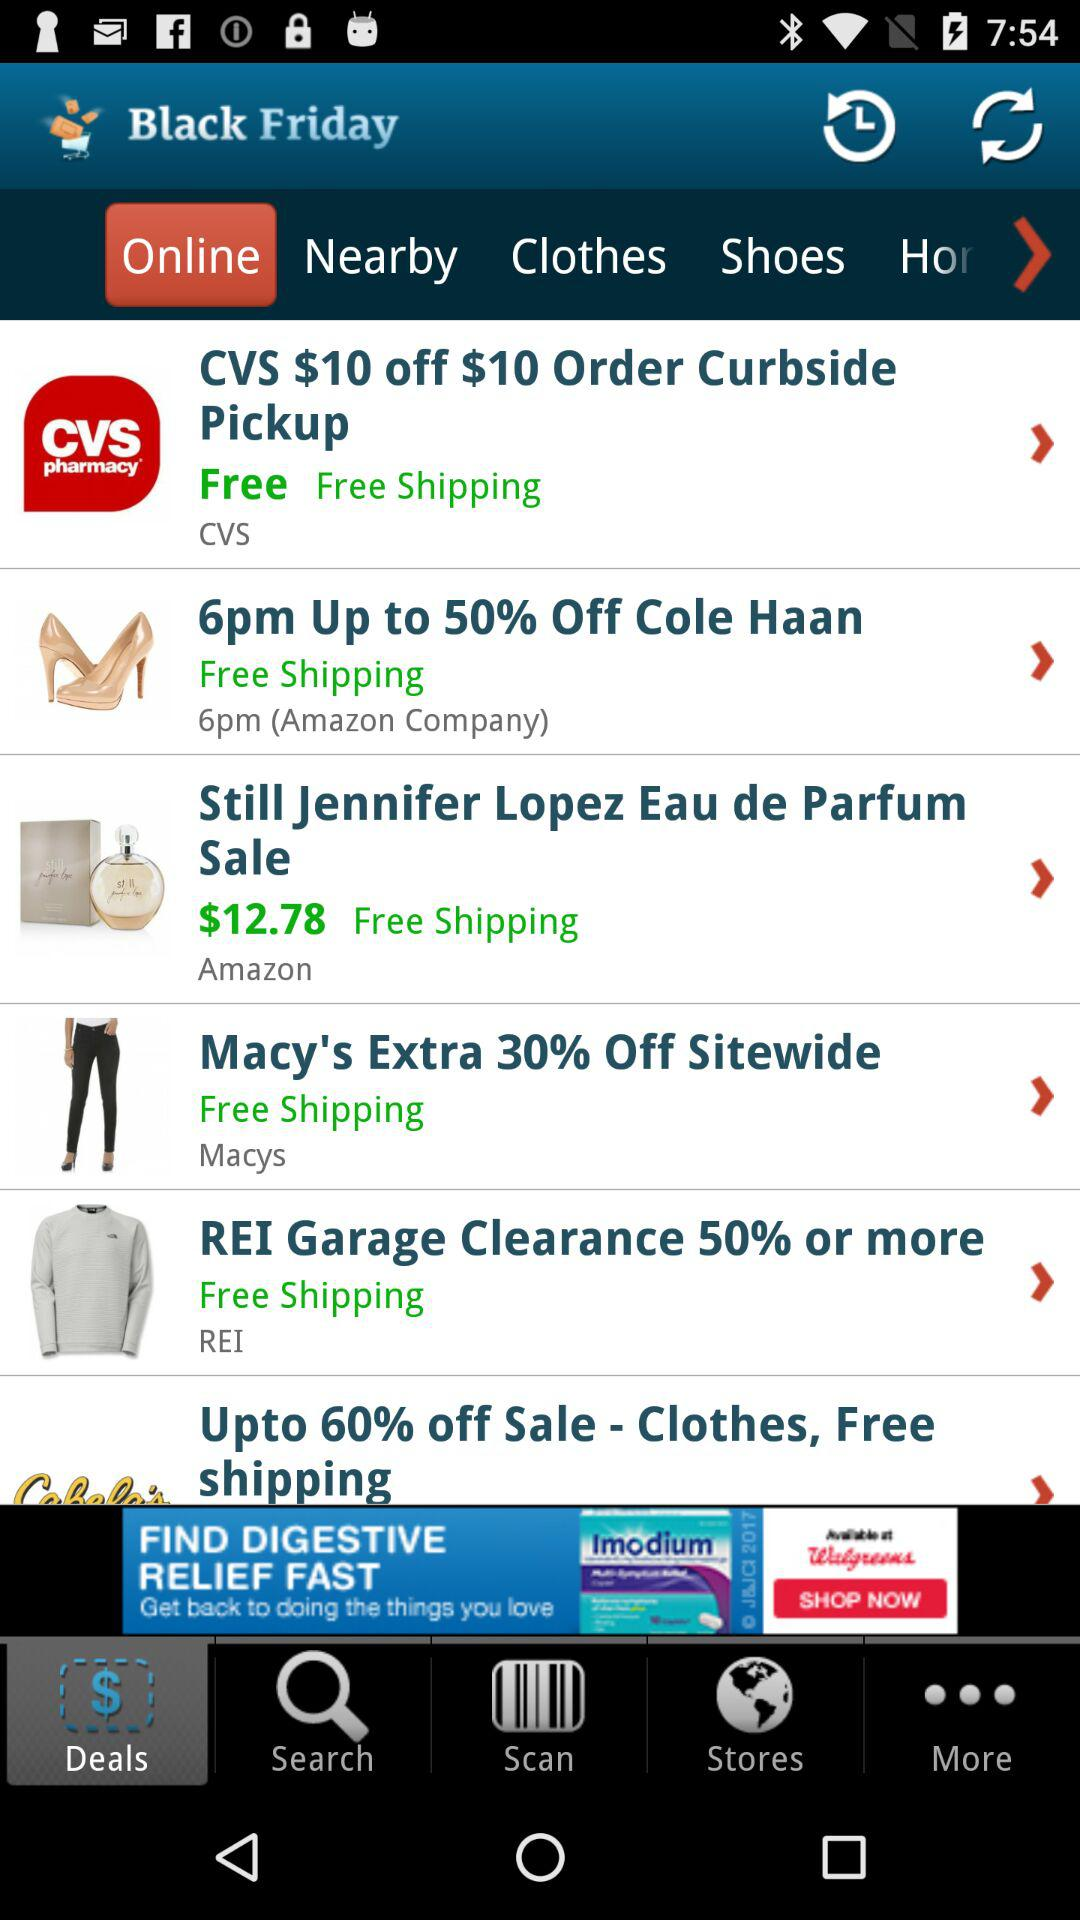Which tab is selected? The selected tabs are "Online" and "Deals". 